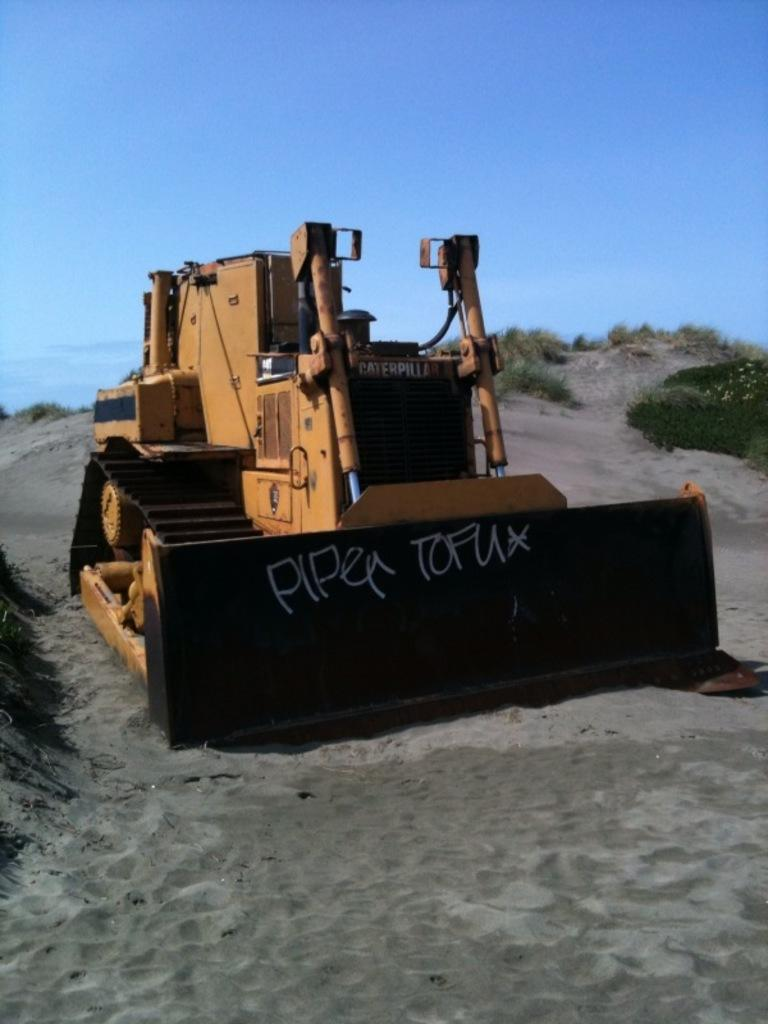What is the main subject in the middle of the image? There is a bulldozer in the middle of the image. What is at the bottom of the image? There is sand at the bottom of the image. What can be seen at the top of the image? The sky is visible at the top of the image. What type of vegetation is present on the right side of the image? There are plants in the soil on the right side of the image. Can you see any ladybugs crawling on the plants in the image? There are no ladybugs visible in the image; only plants can be seen in the soil on the right side of the image. 